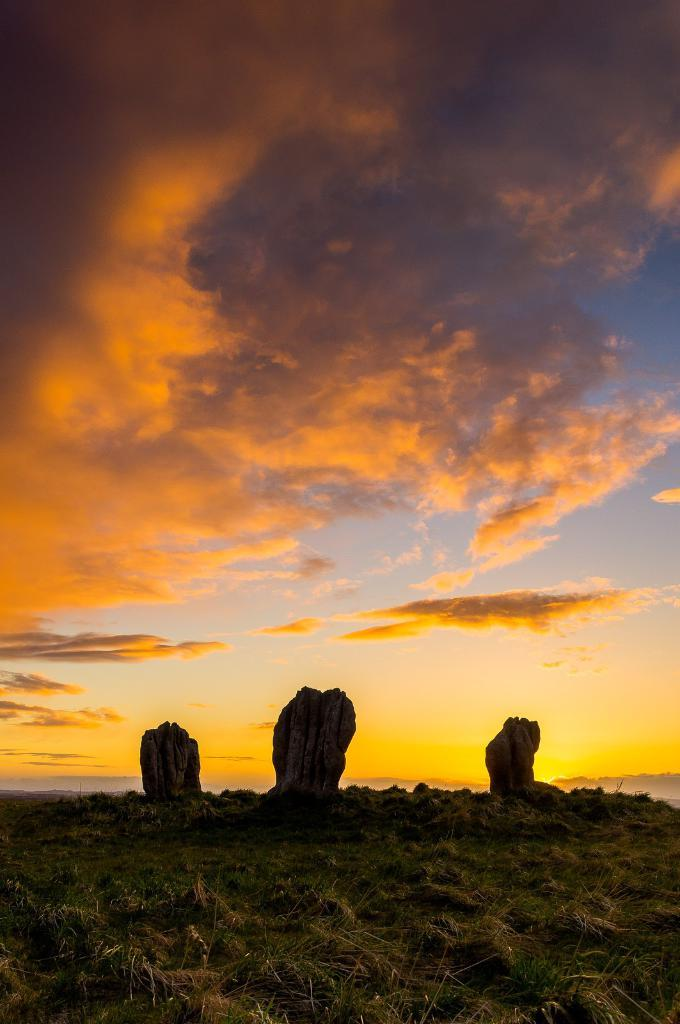What type of vegetation is present at the bottom of the image? There is grass on the ground at the bottom of the image. What objects can be seen in the background of the image? There are three rocks in the background of the image. What is visible at the top of the image? The sky is visible at the top of the image. What can be observed in the sky? Clouds are present in the sky. What type of cabbage is being cut with a knife in the image? There is no cabbage or knife present in the image. How does the image start, and what is the first thing that happens? The image does not have a start or any events happening in a sequence, as it is a static image. 